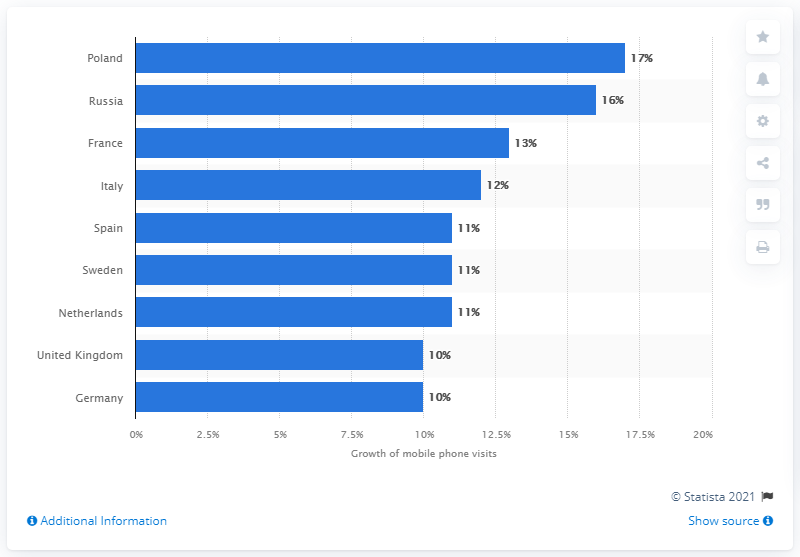Give some essential details in this illustration. According to the data, mobile phone traffic from Poland increased by 17% in 2019. 